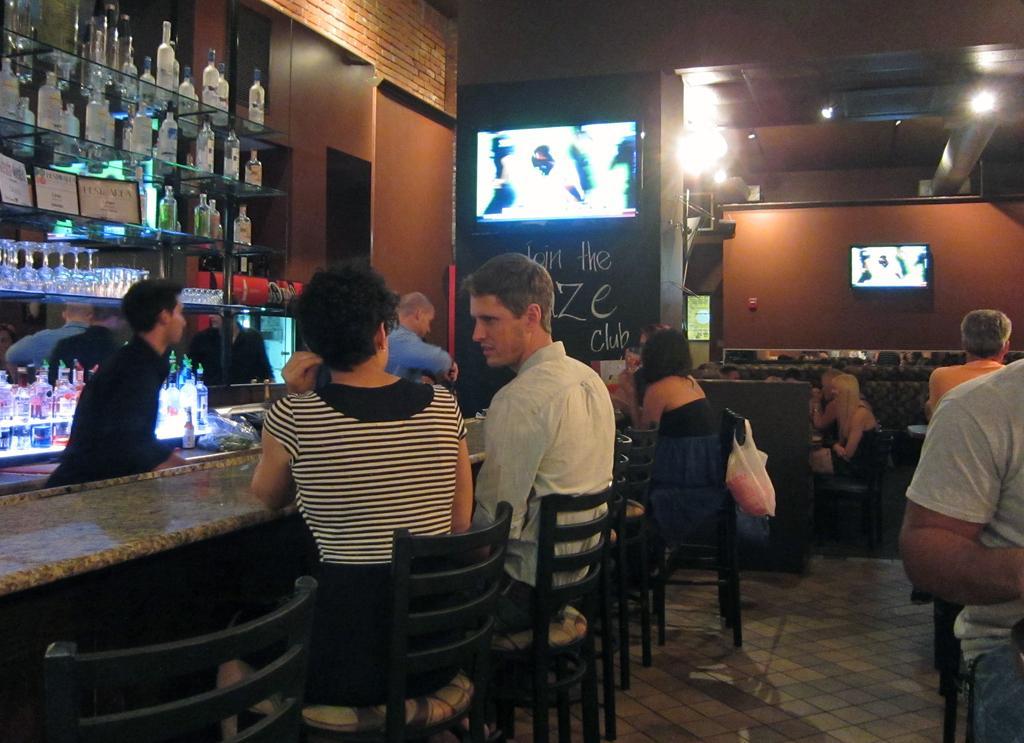Could you give a brief overview of what you see in this image? As we can see in the image there is a rack. The rack is filled with bottles, television, chairs and table and on chairs there are few people sitting. 